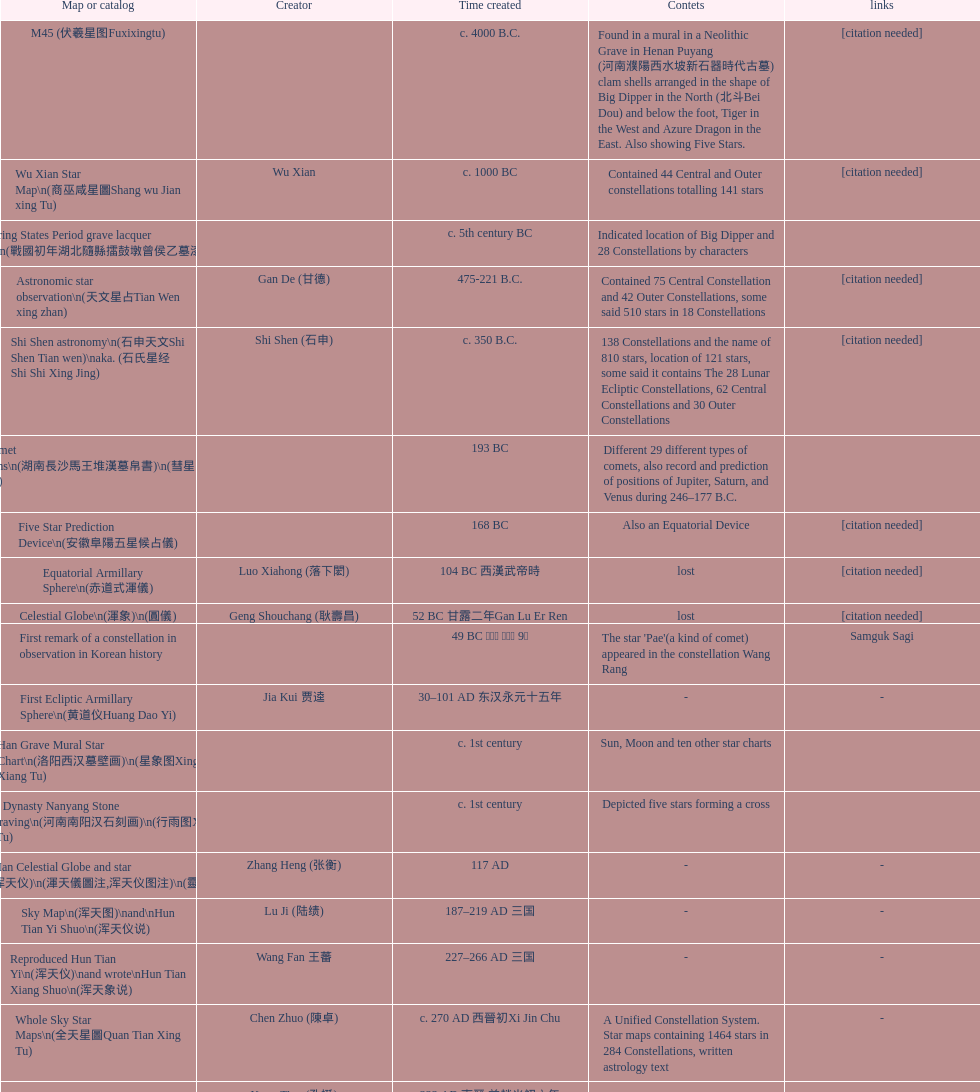What is the discrepancy between the five star prediction device's creation date and the han comet diagrams' creation date? 25 years. 